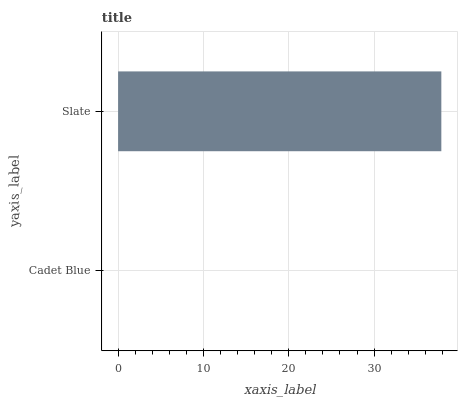Is Cadet Blue the minimum?
Answer yes or no. Yes. Is Slate the maximum?
Answer yes or no. Yes. Is Slate the minimum?
Answer yes or no. No. Is Slate greater than Cadet Blue?
Answer yes or no. Yes. Is Cadet Blue less than Slate?
Answer yes or no. Yes. Is Cadet Blue greater than Slate?
Answer yes or no. No. Is Slate less than Cadet Blue?
Answer yes or no. No. Is Slate the high median?
Answer yes or no. Yes. Is Cadet Blue the low median?
Answer yes or no. Yes. Is Cadet Blue the high median?
Answer yes or no. No. Is Slate the low median?
Answer yes or no. No. 